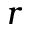Convert formula to latex. <formula><loc_0><loc_0><loc_500><loc_500>r</formula> 